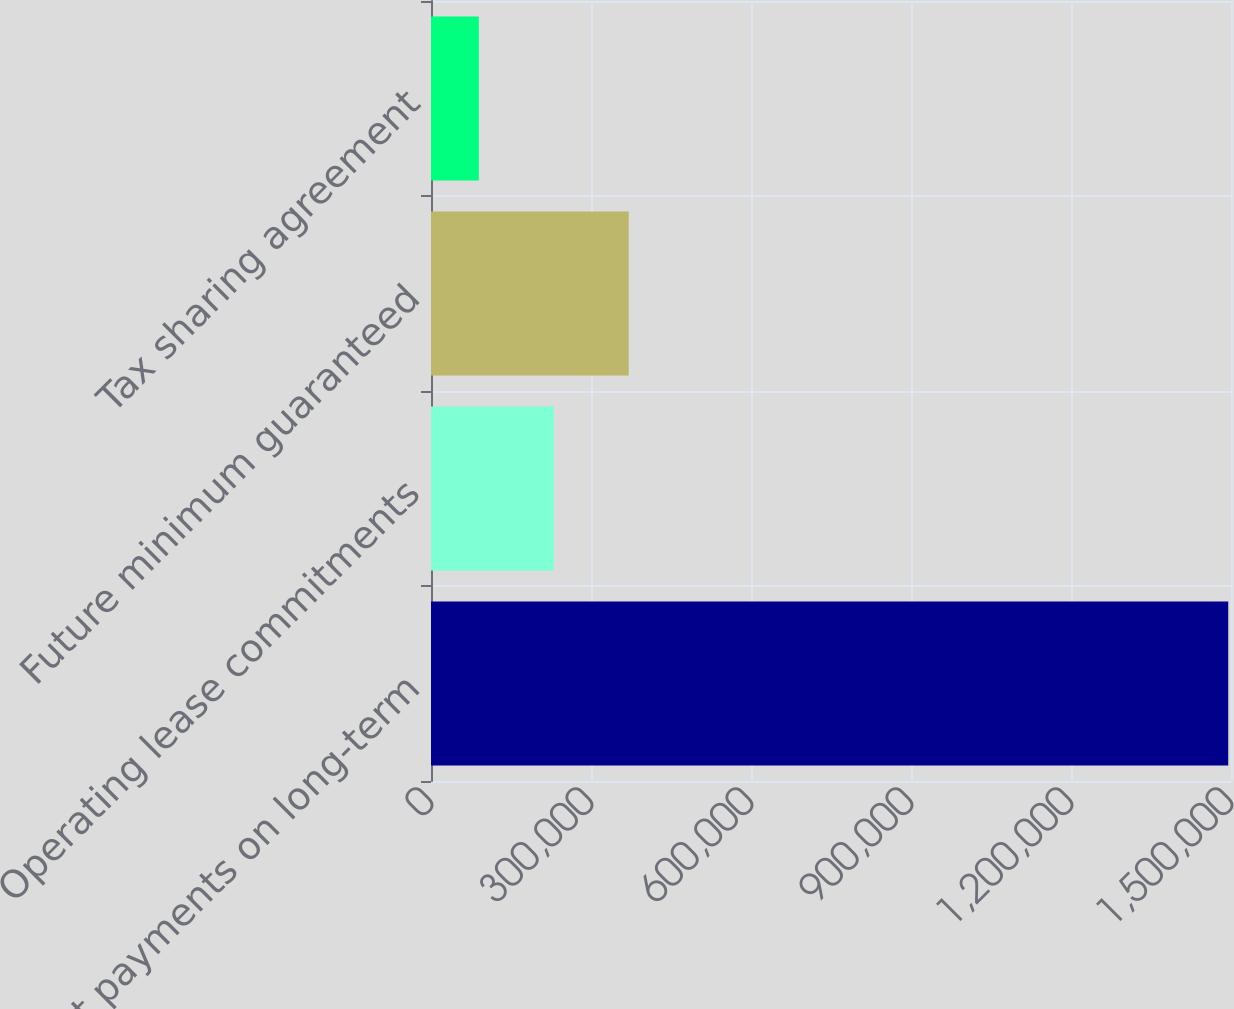<chart> <loc_0><loc_0><loc_500><loc_500><bar_chart><fcel>Interest payments on long-term<fcel>Operating lease commitments<fcel>Future minimum guaranteed<fcel>Tax sharing agreement<nl><fcel>1.49482e+06<fcel>230212<fcel>370724<fcel>89700<nl></chart> 